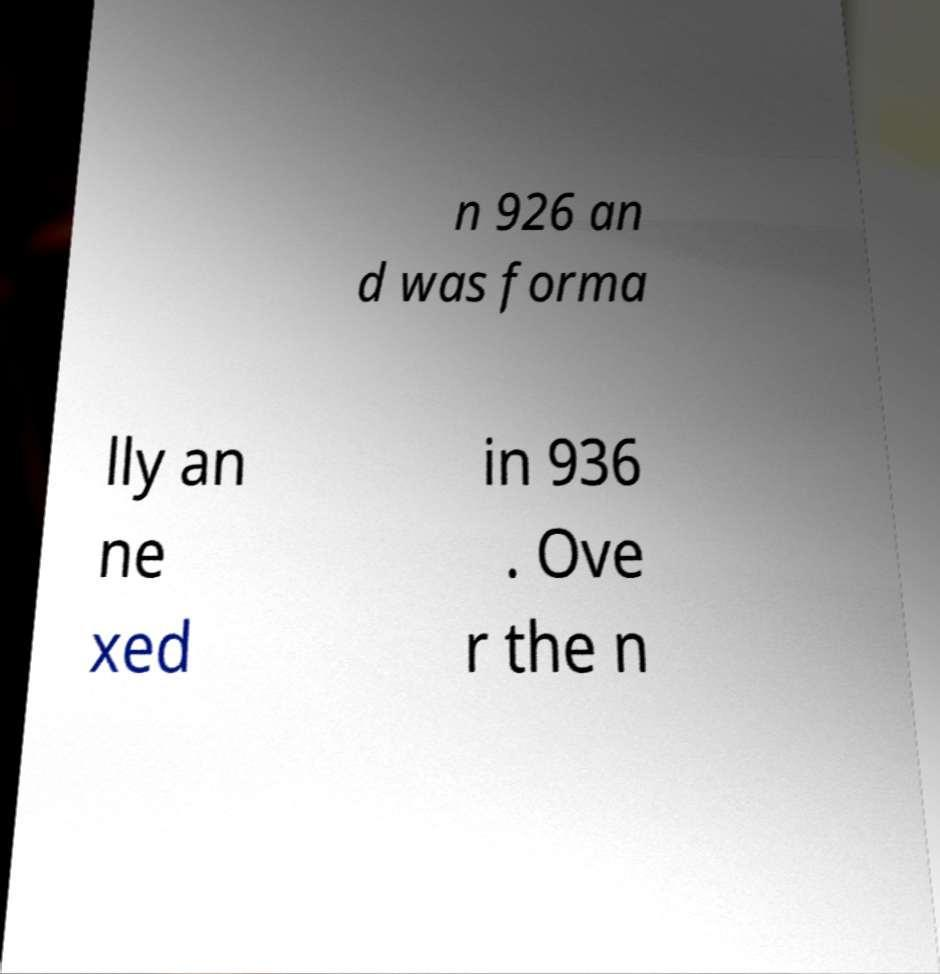What messages or text are displayed in this image? I need them in a readable, typed format. n 926 an d was forma lly an ne xed in 936 . Ove r the n 